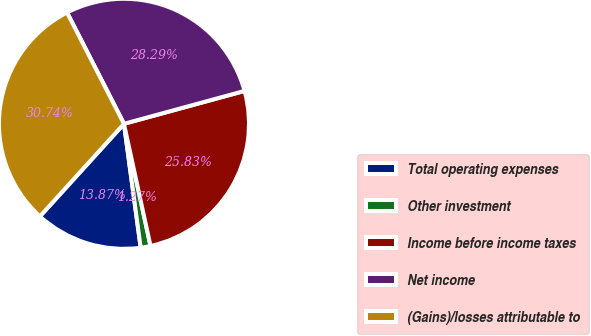Convert chart. <chart><loc_0><loc_0><loc_500><loc_500><pie_chart><fcel>Total operating expenses<fcel>Other investment<fcel>Income before income taxes<fcel>Net income<fcel>(Gains)/losses attributable to<nl><fcel>13.87%<fcel>1.27%<fcel>25.83%<fcel>28.29%<fcel>30.74%<nl></chart> 